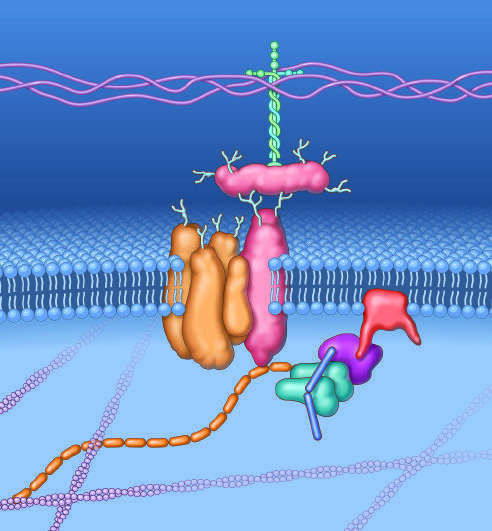what does this complex of glycoproteins serve to couple?
Answer the question using a single word or phrase. The cell membrane and the extracellular matrix proteins 